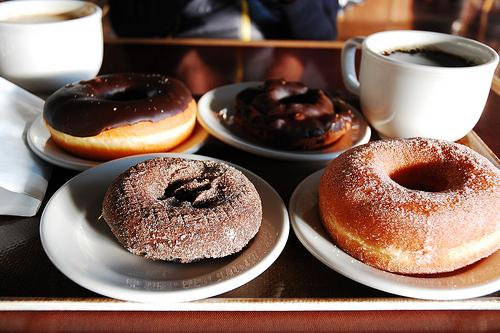In the image, describe the details of the white napkin. The white napkin in the image is placed on the serving tray and has dimensions of Width: 48 and Height: 48. What items are present on the serving tray in the image? The serving tray has pastries, a cup of coffee, and a white napkin. What type of pastry is on a white dish in the image? A chocolate frosted pastry is on a white dish in the image. Identify the predominant color and type of table in the image. The table in the image is predominantly glass. Give a brief description of the scene in the image. The image shows a glass table with doughnuts on plates, a white cup of coffee, and a white napkin, all arranged on a serving tray. Describe the appearance of the doughnuts in the image. There are doughnuts with chocolate glaze and powdered sugar, some have holes in the middle, and they are served on plates. What kind of frosting do the donuts have in the image? The donuts have chocolate frosting and powdered sugar frosting in the image. What is the main beverage being served in the image? The main beverage served is coffee in a white cup. In the image, what object is in back of the chocolate donut? A white cup is in back of the chocolate donut in the image. 